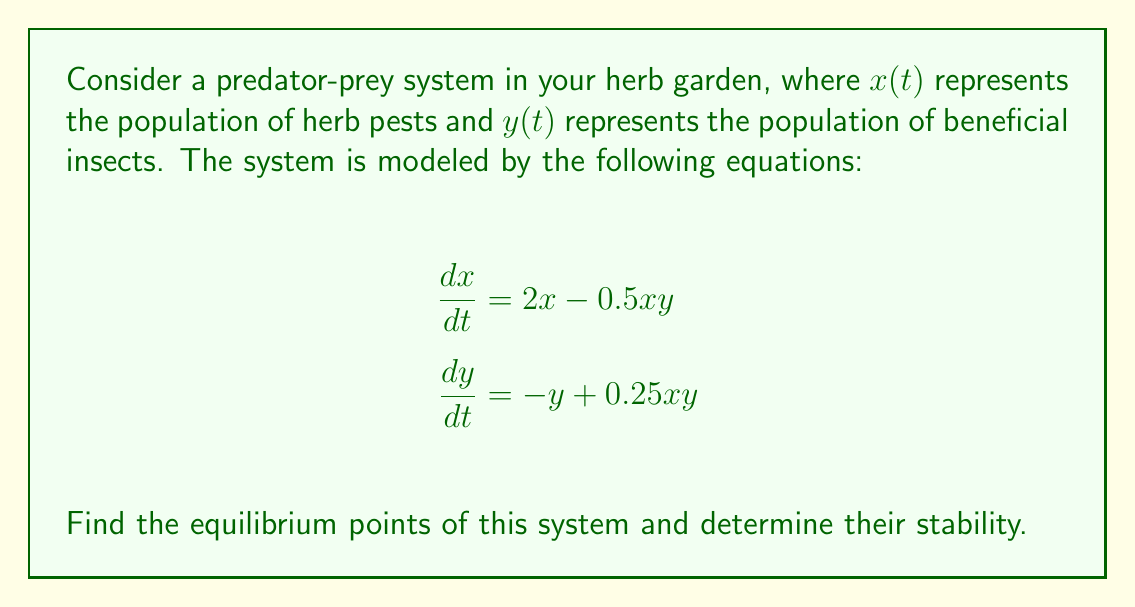Can you solve this math problem? 1) To find the equilibrium points, set both equations to zero:

   $$2x - 0.5xy = 0$$
   $$-y + 0.25xy = 0$$

2) From the second equation:
   $$y(0.25x - 1) = 0$$
   So, either $y = 0$ or $x = 4$

3) If $y = 0$, from the first equation:
   $$2x = 0$$
   So, $x = 0$

4) If $x = 4$, from the first equation:
   $$8 - 2y = 0$$
   So, $y = 4$

5) Therefore, we have two equilibrium points: $(0,0)$ and $(4,4)$

6) To determine stability, we need to find the Jacobian matrix:

   $$J = \begin{bmatrix}
   \frac{\partial}{\partial x}(2x - 0.5xy) & \frac{\partial}{\partial y}(2x - 0.5xy) \\
   \frac{\partial}{\partial x}(-y + 0.25xy) & \frac{\partial}{\partial y}(-y + 0.25xy)
   \end{bmatrix}
   = \begin{bmatrix}
   2 - 0.5y & -0.5x \\
   0.25y & -1 + 0.25x
   \end{bmatrix}$$

7) For $(0,0)$:
   $$J_{(0,0)} = \begin{bmatrix}
   2 & 0 \\
   0 & -1
   \end{bmatrix}$$
   Eigenvalues are 2 and -1. Since one is positive, $(0,0)$ is unstable.

8) For $(4,4)$:
   $$J_{(4,4)} = \begin{bmatrix}
   0 & -2 \\
   1 & 0
   \end{bmatrix}$$
   Characteristic equation: $\lambda^2 + 2 = 0$
   Eigenvalues: $\lambda = \pm i\sqrt{2}$
   Since both eigenvalues are purely imaginary, $(4,4)$ is a center (neutrally stable).
Answer: Equilibrium points: $(0,0)$ (unstable) and $(4,4)$ (neutrally stable). 